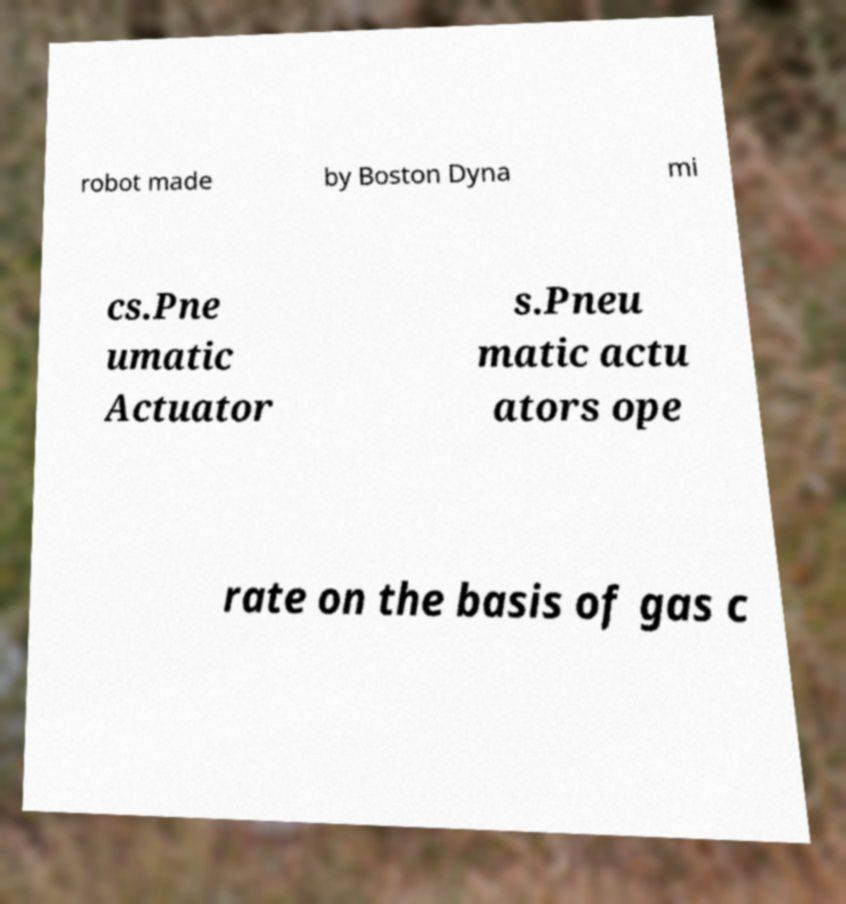Can you read and provide the text displayed in the image?This photo seems to have some interesting text. Can you extract and type it out for me? robot made by Boston Dyna mi cs.Pne umatic Actuator s.Pneu matic actu ators ope rate on the basis of gas c 